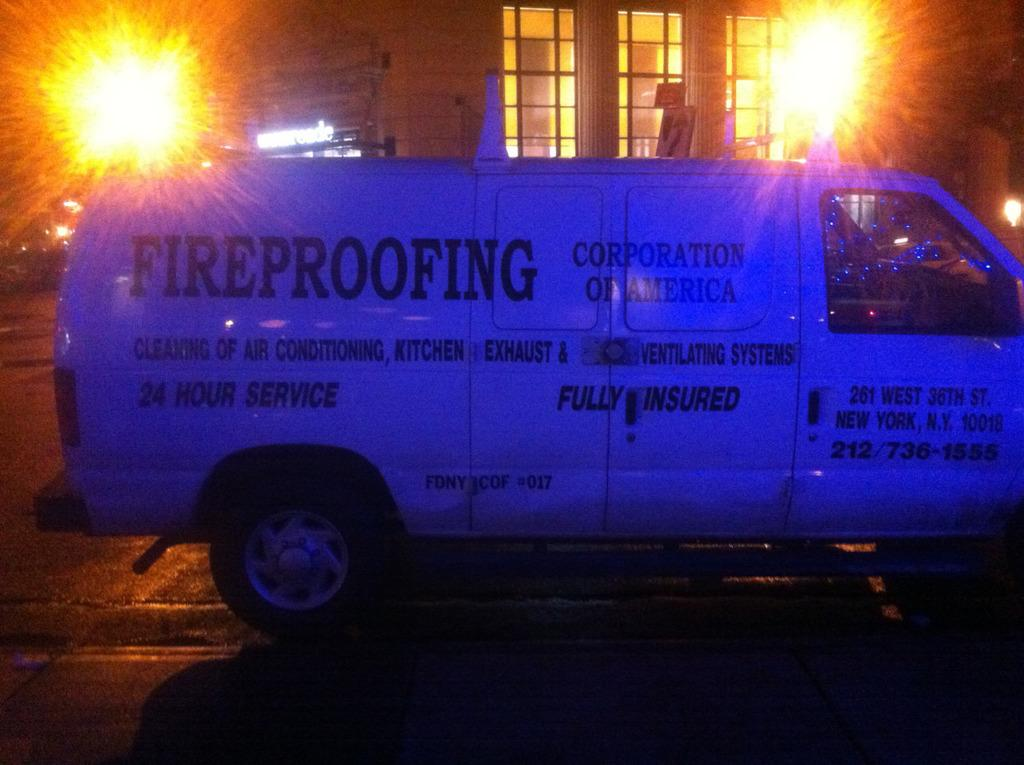<image>
Describe the image concisely. A white company van for a fireproofing company is parked in a dark street. 